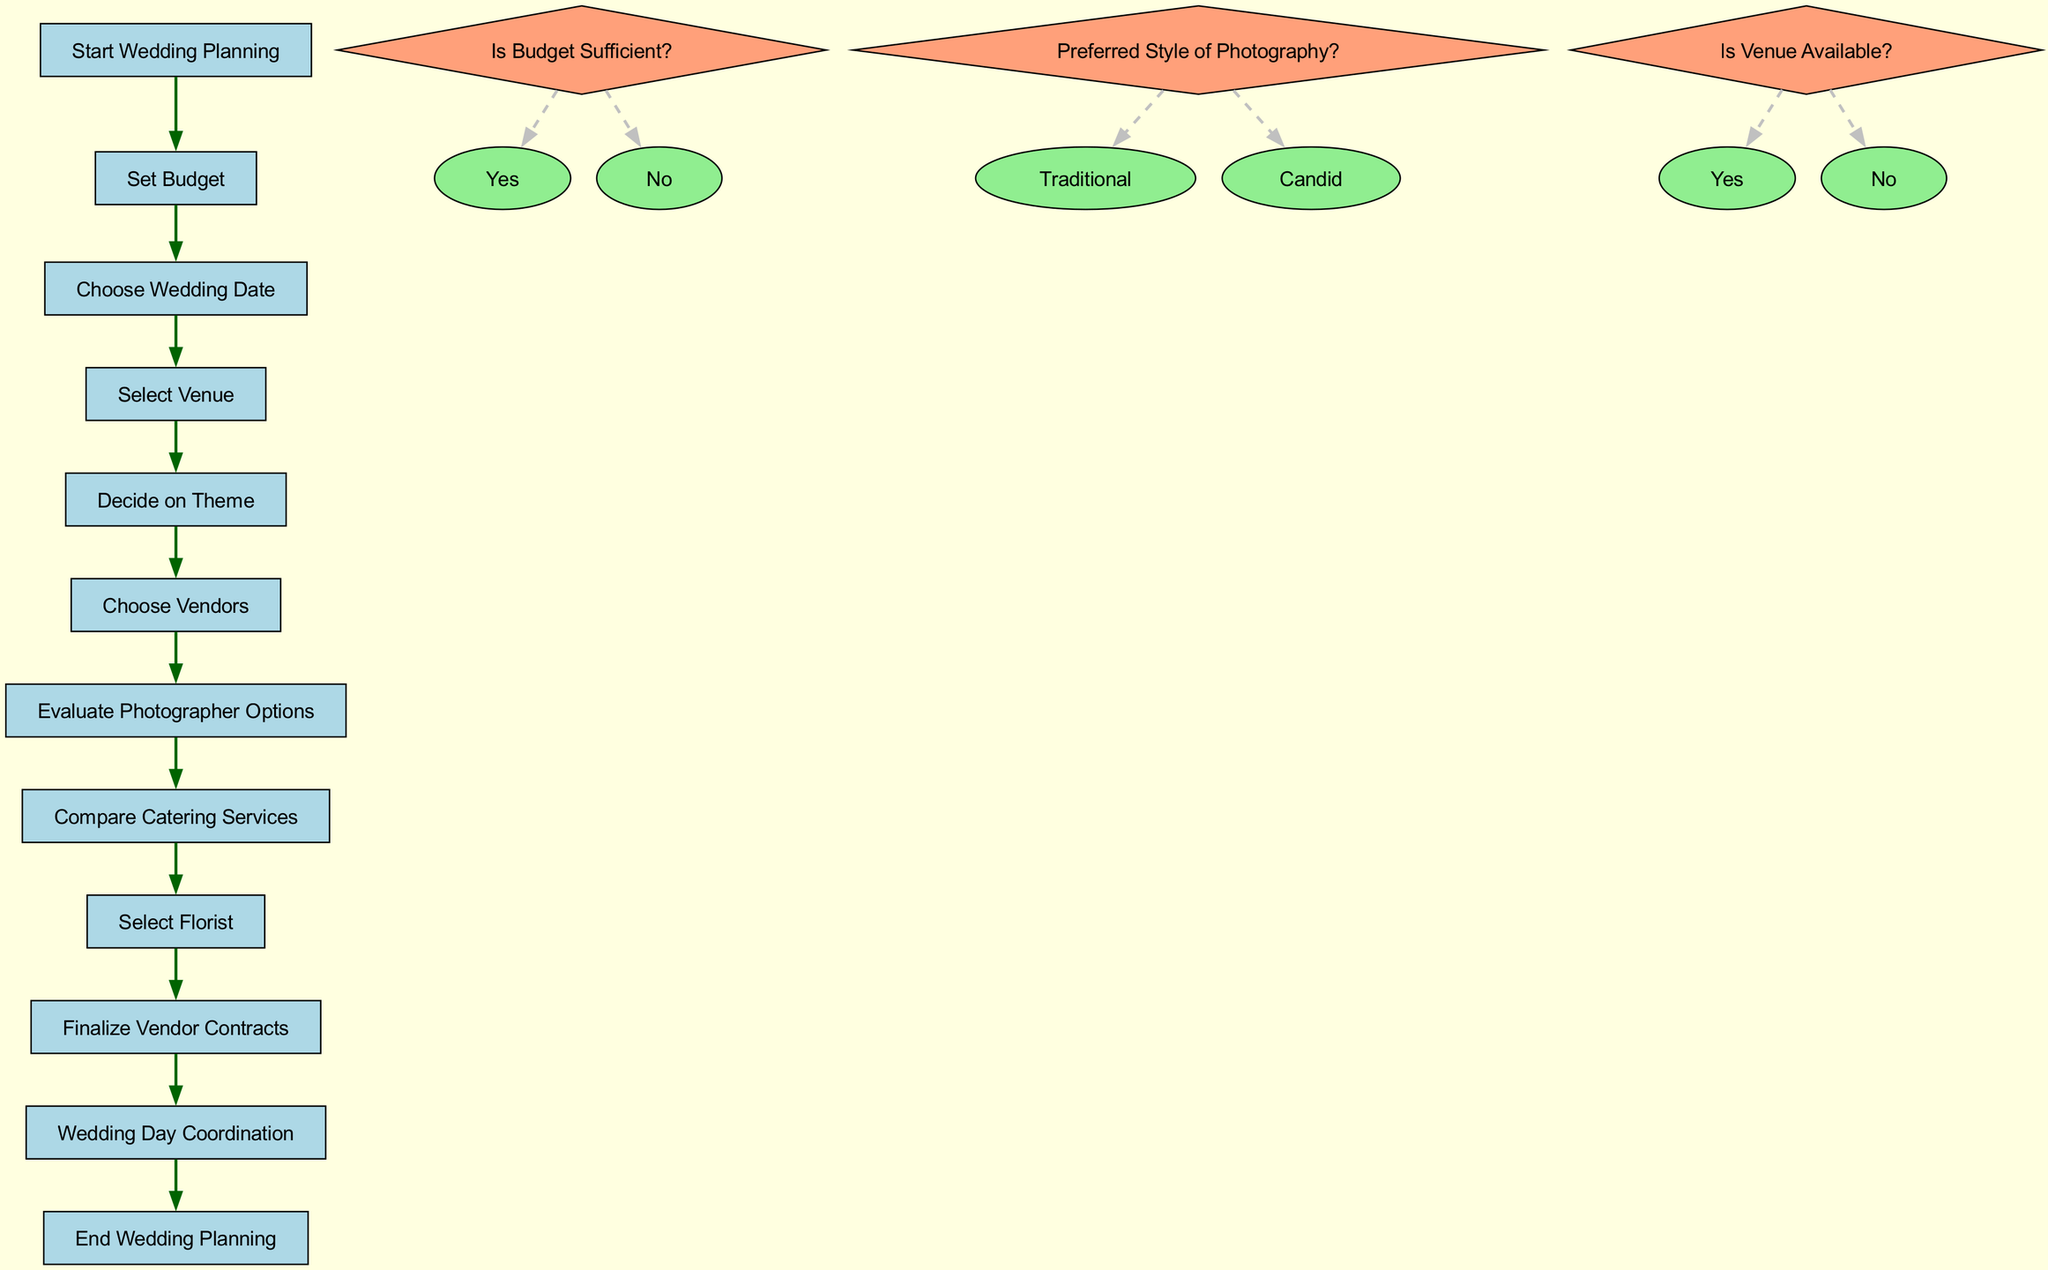What is the starting point of the wedding planning process? The diagram indicates that the first node is "Start Wedding Planning", which is where the process begins.
Answer: Start Wedding Planning How many decision points are included in the diagram? The diagram contains three decision points listed, indicating key questions that must be answered during the process.
Answer: 3 What comes after choosing vendors in the process? The diagram shows that the next step after "Choose Vendors" is "Evaluate Photographer Options", indicating a clear sequence.
Answer: Evaluate Photographer Options Is there a decision point regarding the venue availability? Reviewing the decision points in the diagram, there is a question labeled "Is Venue Available?" confirming that venue availability is considered.
Answer: Yes What is the last step in the wedding planning process? The diagram concludes with "End Wedding Planning", which represents the final node in the flow of the process.
Answer: End Wedding Planning What is the option available if the budget is not sufficient? The decision point "Is Budget Sufficient?" provides two options; if the answer is "No", it indicates that adjustments or reconsiderations may be needed, but it is not explicitly listed in the diagram.
Answer: No If the preferred style of photography is Candid, what is the next step? The decision point labeled "Preferred Style of Photography?" shows options, and if "Candid" is chosen, it implies there's a subsequent filter or evaluation in the process after vendor selection. However, the next step is not specified in the diagram.
Answer: Not specified How are the edges in the diagram represented? Each edge in the diagram indicates a directed relationship between nodes, connecting each process step sequentially, as shown visually in the flow.
Answer: Directed relationships What is the relationship between the "Select Venue" and "Decide on Theme"? The diagram indicates that "Select Venue" must be completed before moving on to "Decide on Theme", demonstrating a sequential process link.
Answer: Sequential process link 